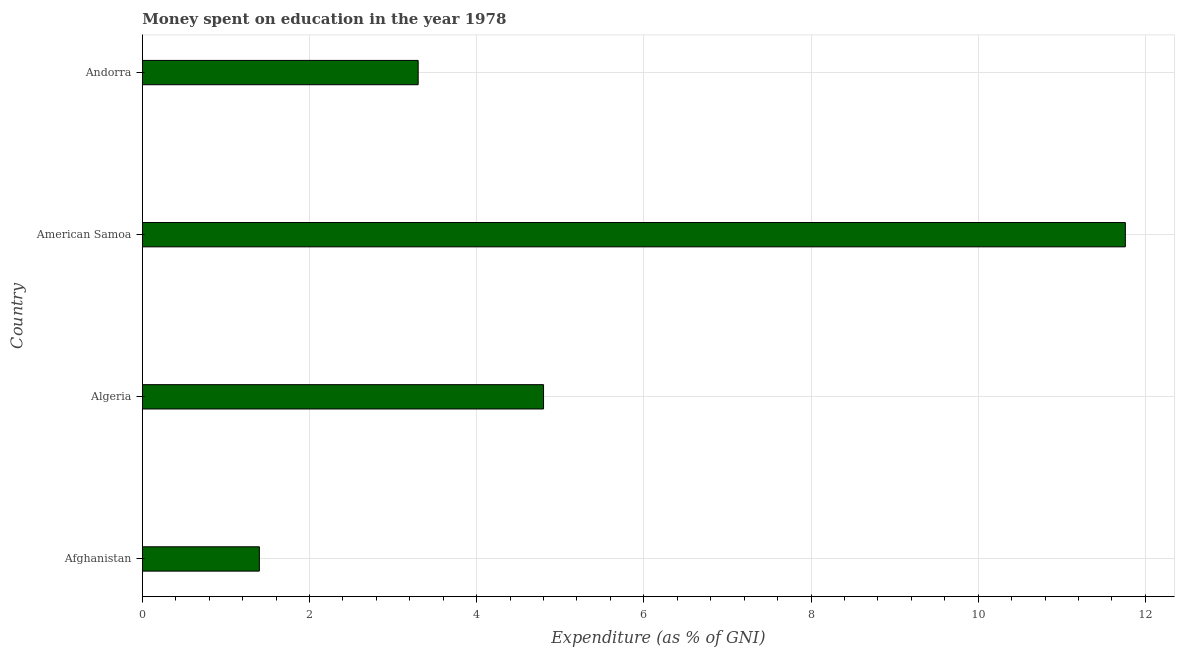What is the title of the graph?
Offer a very short reply. Money spent on education in the year 1978. What is the label or title of the X-axis?
Your answer should be compact. Expenditure (as % of GNI). What is the expenditure on education in Afghanistan?
Your answer should be very brief. 1.4. Across all countries, what is the maximum expenditure on education?
Provide a short and direct response. 11.76. Across all countries, what is the minimum expenditure on education?
Your answer should be very brief. 1.4. In which country was the expenditure on education maximum?
Provide a succinct answer. American Samoa. In which country was the expenditure on education minimum?
Offer a very short reply. Afghanistan. What is the sum of the expenditure on education?
Your response must be concise. 21.26. What is the difference between the expenditure on education in Afghanistan and American Samoa?
Your answer should be very brief. -10.36. What is the average expenditure on education per country?
Keep it short and to the point. 5.32. What is the median expenditure on education?
Your answer should be compact. 4.05. What is the ratio of the expenditure on education in Algeria to that in American Samoa?
Provide a succinct answer. 0.41. Is the difference between the expenditure on education in American Samoa and Andorra greater than the difference between any two countries?
Your answer should be very brief. No. What is the difference between the highest and the second highest expenditure on education?
Give a very brief answer. 6.96. Is the sum of the expenditure on education in Afghanistan and Algeria greater than the maximum expenditure on education across all countries?
Keep it short and to the point. No. What is the difference between the highest and the lowest expenditure on education?
Make the answer very short. 10.36. How many bars are there?
Offer a very short reply. 4. Are all the bars in the graph horizontal?
Ensure brevity in your answer.  Yes. How many countries are there in the graph?
Keep it short and to the point. 4. What is the Expenditure (as % of GNI) in Afghanistan?
Provide a short and direct response. 1.4. What is the Expenditure (as % of GNI) of American Samoa?
Keep it short and to the point. 11.76. What is the difference between the Expenditure (as % of GNI) in Afghanistan and Algeria?
Offer a very short reply. -3.4. What is the difference between the Expenditure (as % of GNI) in Afghanistan and American Samoa?
Your response must be concise. -10.36. What is the difference between the Expenditure (as % of GNI) in Afghanistan and Andorra?
Ensure brevity in your answer.  -1.9. What is the difference between the Expenditure (as % of GNI) in Algeria and American Samoa?
Ensure brevity in your answer.  -6.96. What is the difference between the Expenditure (as % of GNI) in Algeria and Andorra?
Your response must be concise. 1.5. What is the difference between the Expenditure (as % of GNI) in American Samoa and Andorra?
Keep it short and to the point. 8.46. What is the ratio of the Expenditure (as % of GNI) in Afghanistan to that in Algeria?
Ensure brevity in your answer.  0.29. What is the ratio of the Expenditure (as % of GNI) in Afghanistan to that in American Samoa?
Make the answer very short. 0.12. What is the ratio of the Expenditure (as % of GNI) in Afghanistan to that in Andorra?
Provide a succinct answer. 0.42. What is the ratio of the Expenditure (as % of GNI) in Algeria to that in American Samoa?
Your answer should be very brief. 0.41. What is the ratio of the Expenditure (as % of GNI) in Algeria to that in Andorra?
Offer a very short reply. 1.46. What is the ratio of the Expenditure (as % of GNI) in American Samoa to that in Andorra?
Give a very brief answer. 3.56. 